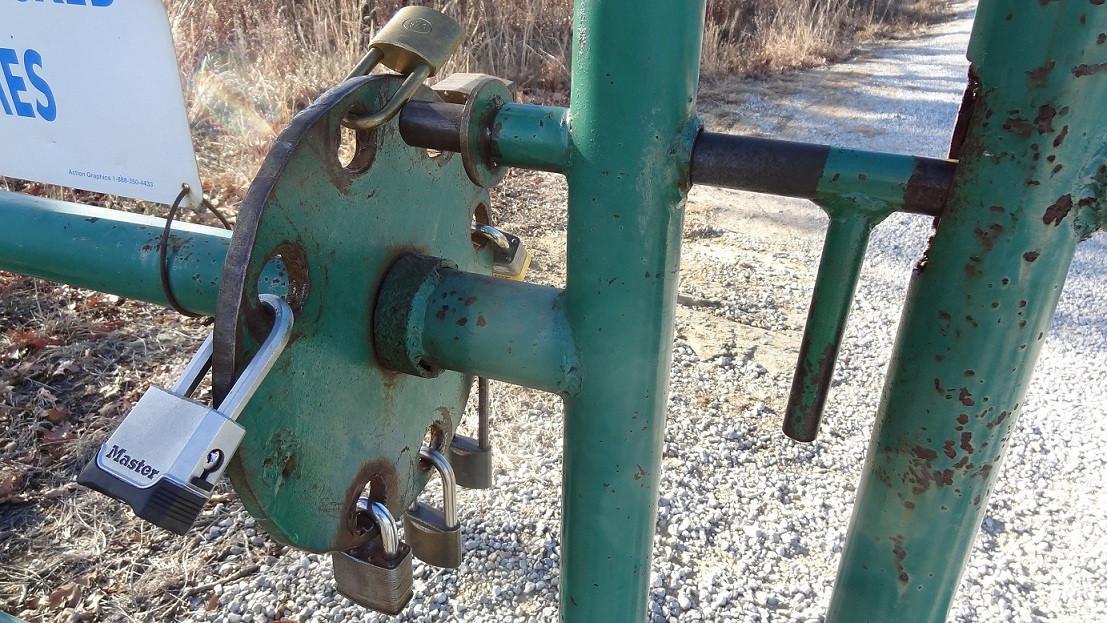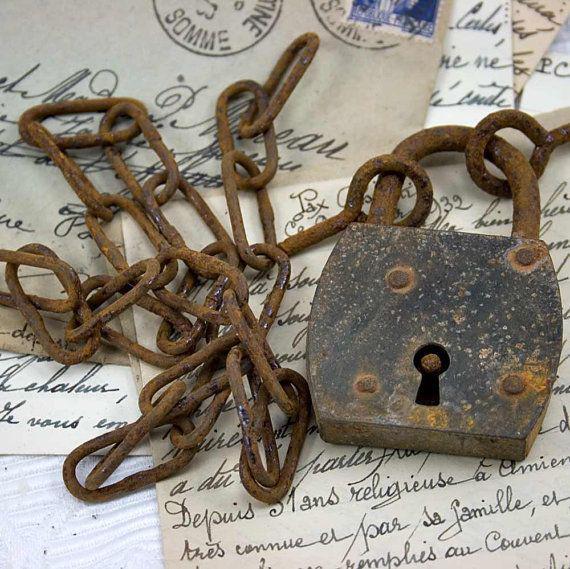The first image is the image on the left, the second image is the image on the right. Considering the images on both sides, is "One image contains exactly one padlock." valid? Answer yes or no. Yes. The first image is the image on the left, the second image is the image on the right. Given the left and right images, does the statement "Multiple squarish padlocks are attached to openings in something made of greenish metal." hold true? Answer yes or no. Yes. 